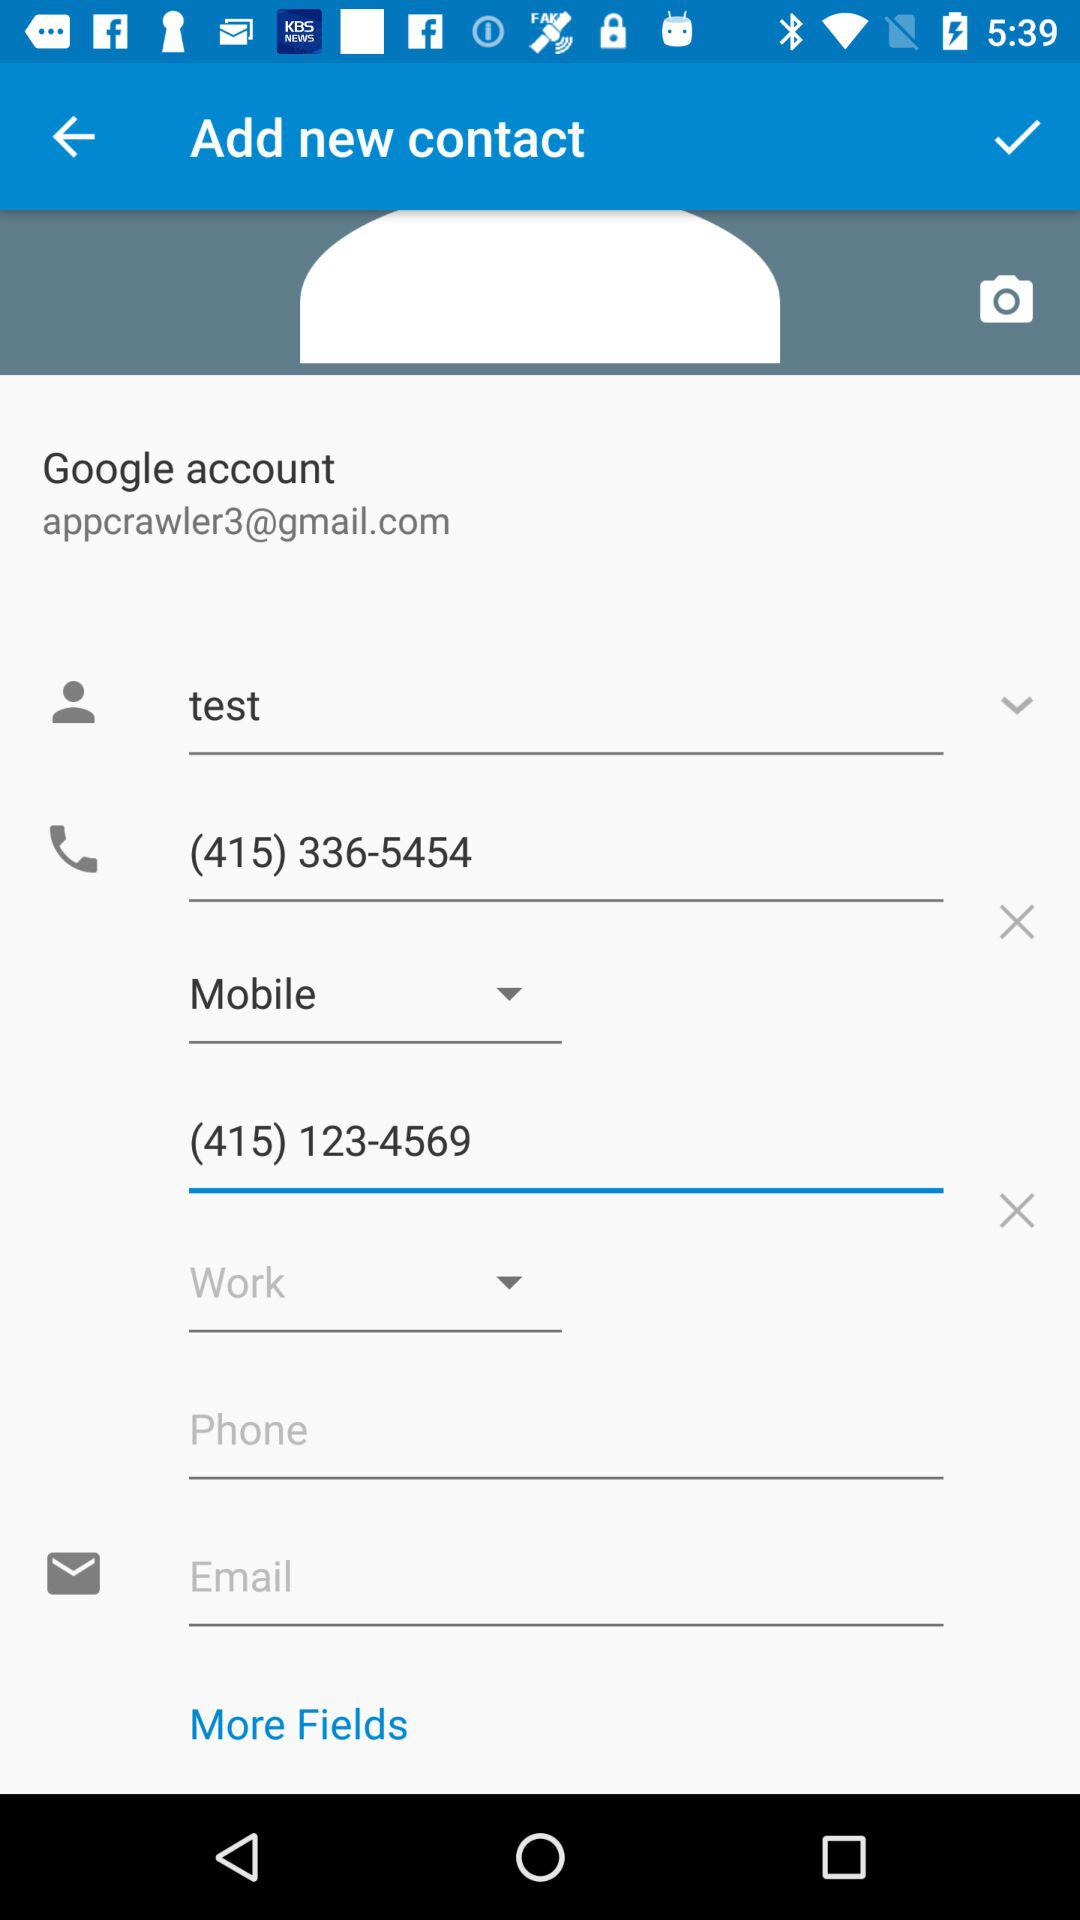What is the name of the user? The name of the user is Test. 